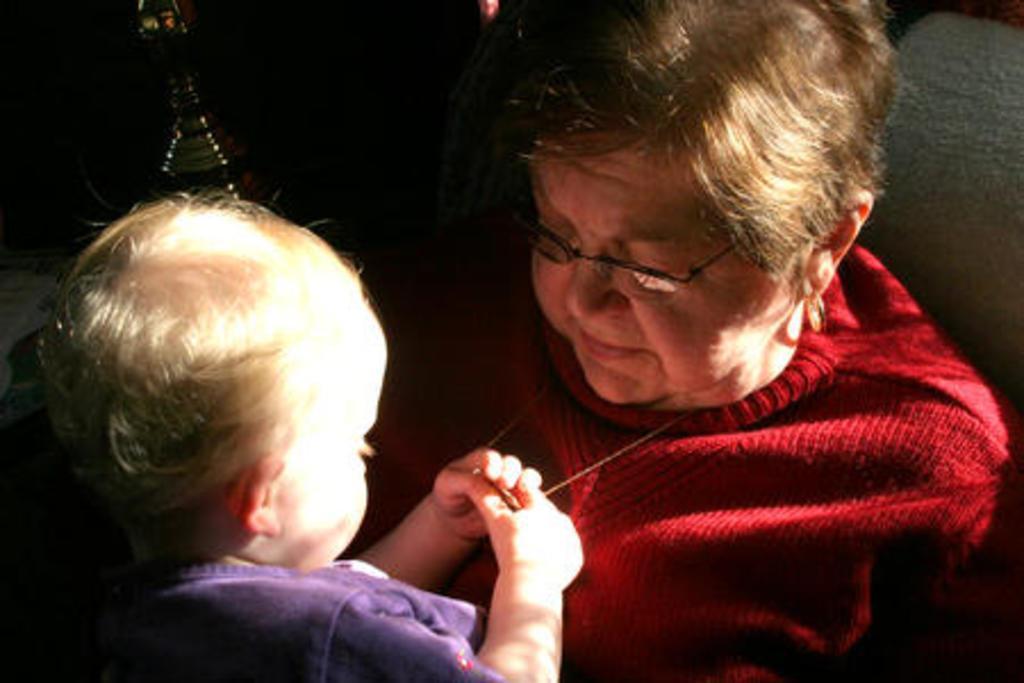How would you summarize this image in a sentence or two? In this picture we can see a woman wore a spectacle and smiling, child holding a locket with hands and in the background it is dark. 